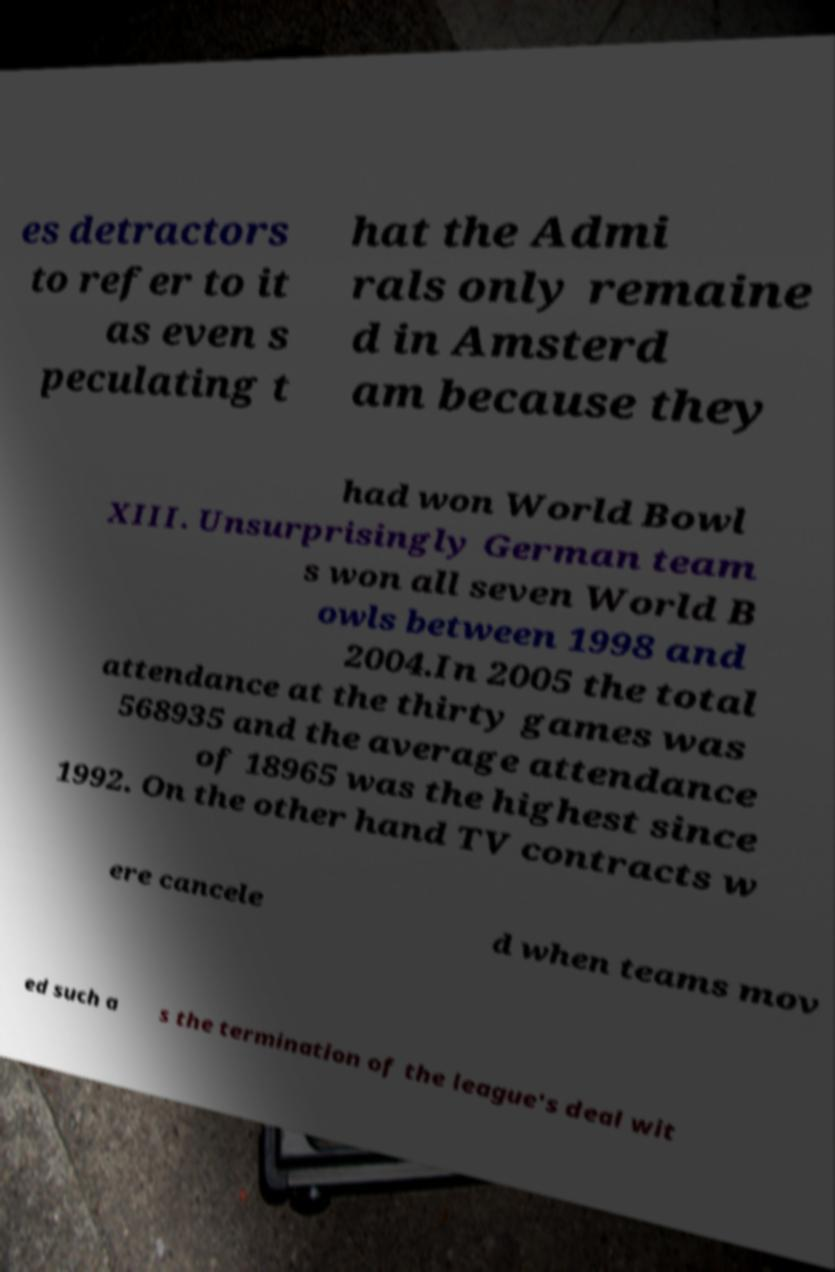Can you accurately transcribe the text from the provided image for me? es detractors to refer to it as even s peculating t hat the Admi rals only remaine d in Amsterd am because they had won World Bowl XIII. Unsurprisingly German team s won all seven World B owls between 1998 and 2004.In 2005 the total attendance at the thirty games was 568935 and the average attendance of 18965 was the highest since 1992. On the other hand TV contracts w ere cancele d when teams mov ed such a s the termination of the league's deal wit 